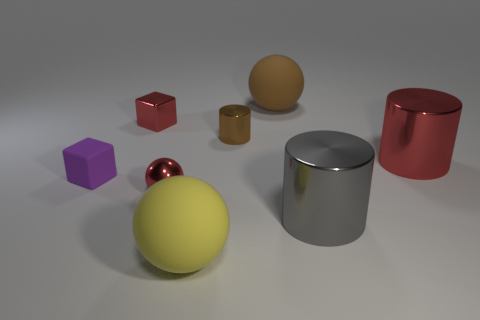Add 1 purple rubber cubes. How many objects exist? 9 Subtract all balls. How many objects are left? 5 Subtract all small gray blocks. Subtract all large red shiny cylinders. How many objects are left? 7 Add 3 tiny purple blocks. How many tiny purple blocks are left? 4 Add 8 large blue rubber cylinders. How many large blue rubber cylinders exist? 8 Subtract 0 blue cylinders. How many objects are left? 8 